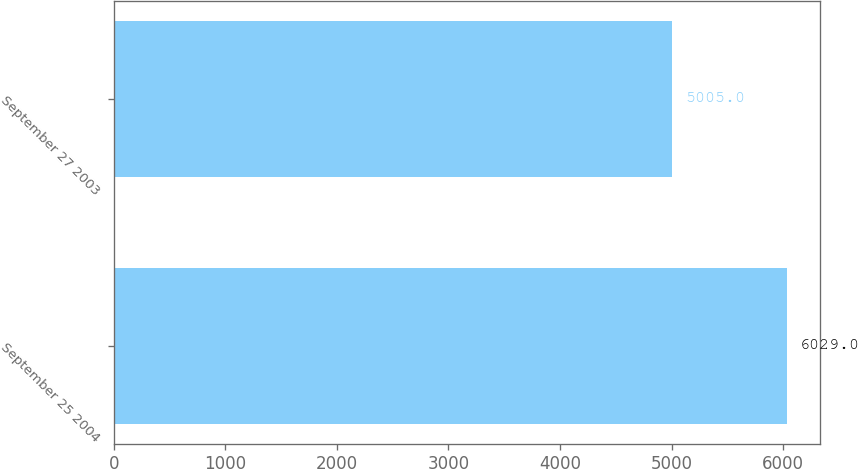<chart> <loc_0><loc_0><loc_500><loc_500><bar_chart><fcel>September 25 2004<fcel>September 27 2003<nl><fcel>6029<fcel>5005<nl></chart> 